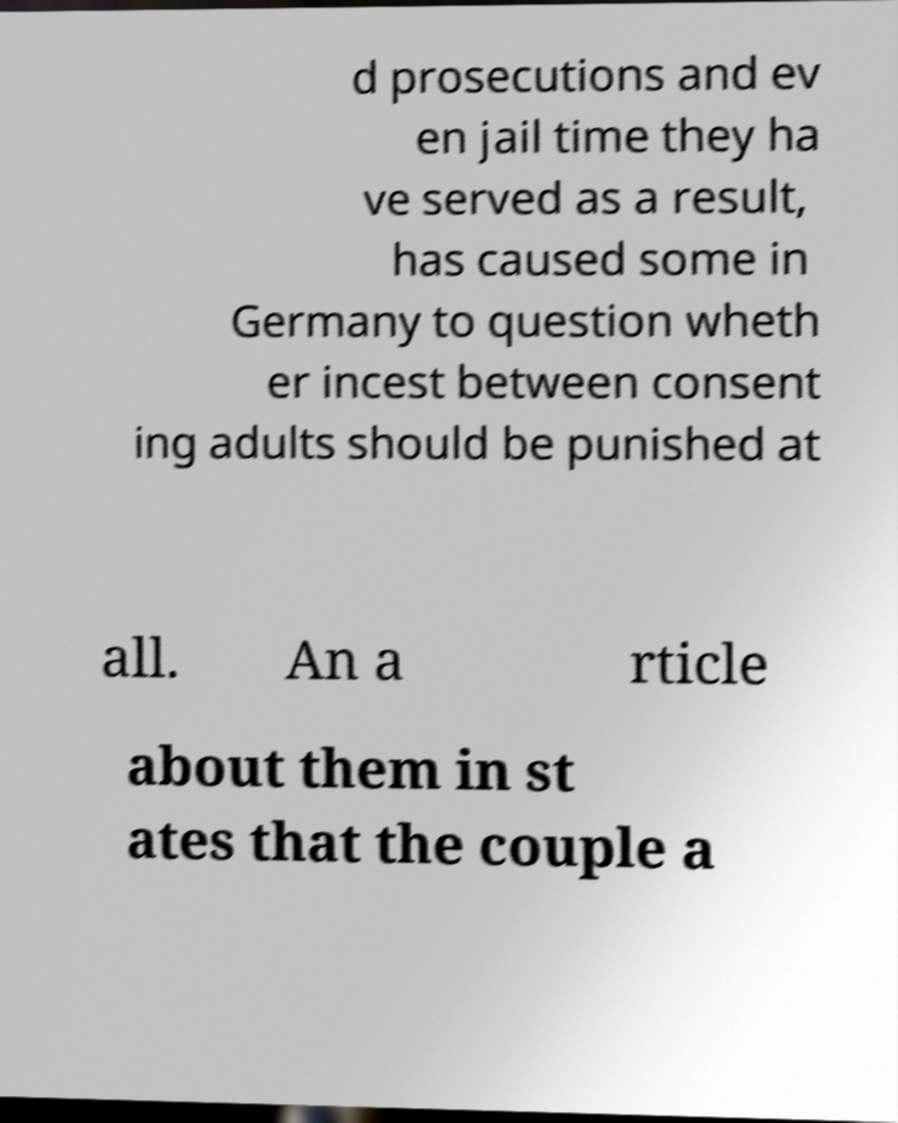Can you accurately transcribe the text from the provided image for me? d prosecutions and ev en jail time they ha ve served as a result, has caused some in Germany to question wheth er incest between consent ing adults should be punished at all. An a rticle about them in st ates that the couple a 